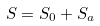<formula> <loc_0><loc_0><loc_500><loc_500>S = S _ { 0 } + S _ { a }</formula> 